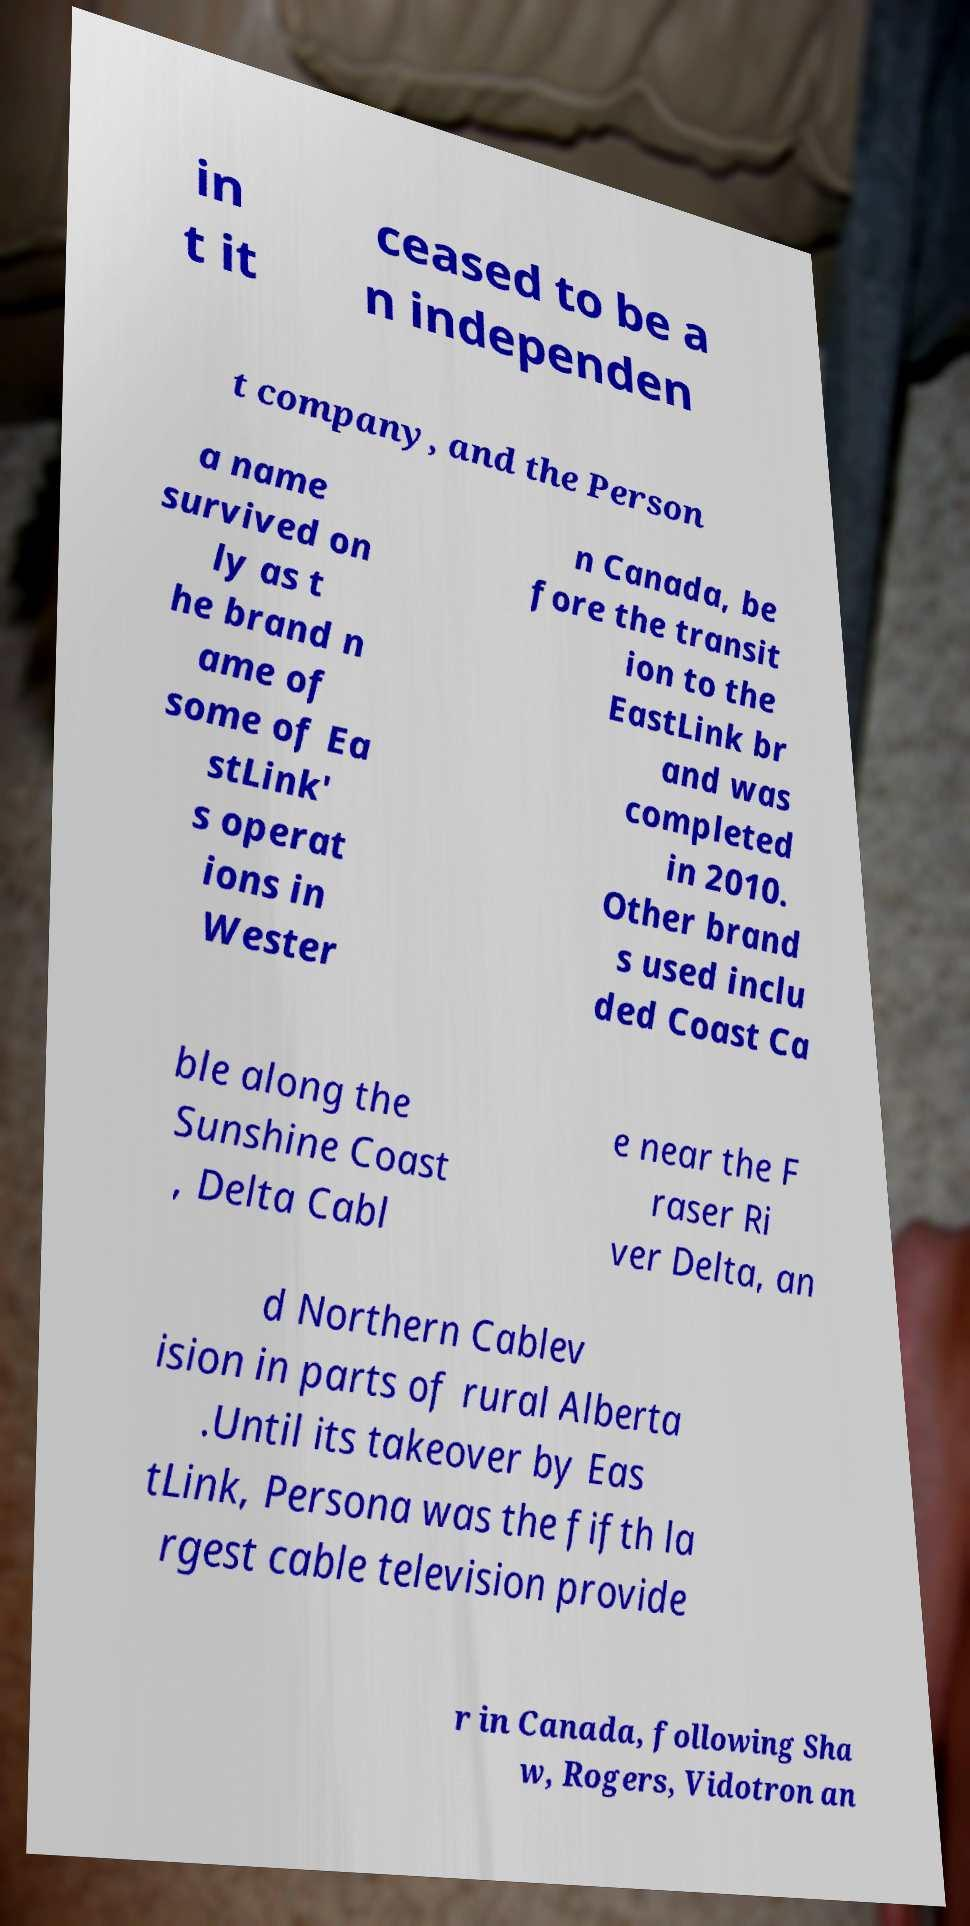Can you read and provide the text displayed in the image?This photo seems to have some interesting text. Can you extract and type it out for me? in t it ceased to be a n independen t company, and the Person a name survived on ly as t he brand n ame of some of Ea stLink' s operat ions in Wester n Canada, be fore the transit ion to the EastLink br and was completed in 2010. Other brand s used inclu ded Coast Ca ble along the Sunshine Coast , Delta Cabl e near the F raser Ri ver Delta, an d Northern Cablev ision in parts of rural Alberta .Until its takeover by Eas tLink, Persona was the fifth la rgest cable television provide r in Canada, following Sha w, Rogers, Vidotron an 